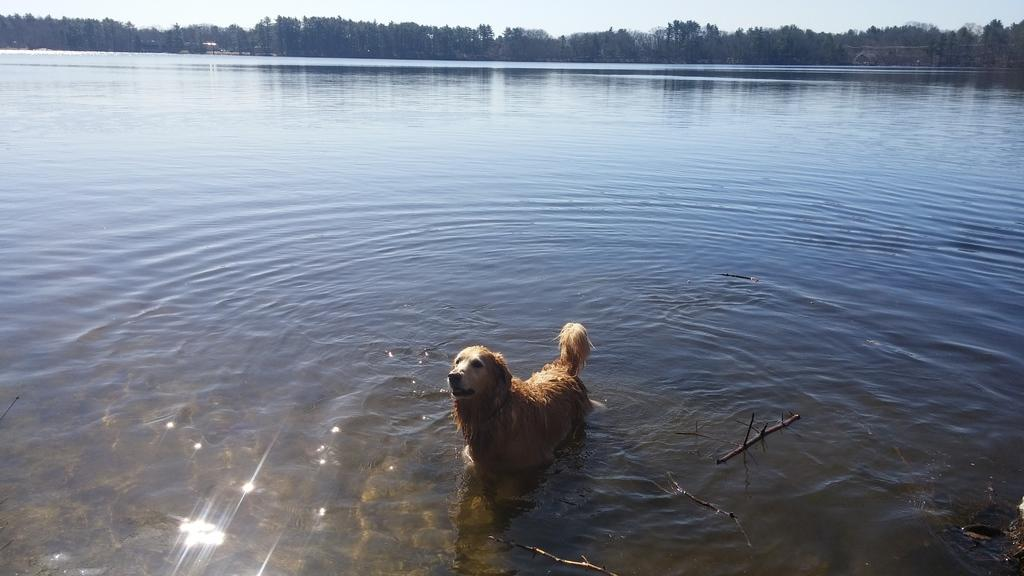What animal can be seen in the image? There is a dog in the image. Where is the dog located in the image? The dog is standing in river water. What type of vegetation is visible in the image? There are trees visible in the image. What part of the natural environment is visible above the trees? The sky is visible above the trees. What type of garden can be seen in the image? There is no garden present in the image; it features a dog standing in river water with trees and sky visible. How many worms are crawling on the dog in the image? There are no worms visible in the image; it only shows a dog standing in river water with trees and sky visible. 